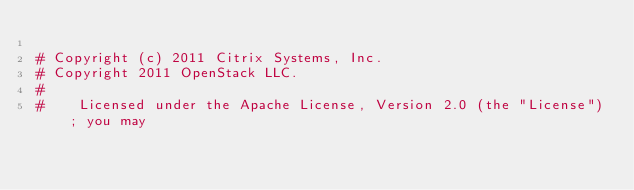Convert code to text. <code><loc_0><loc_0><loc_500><loc_500><_Python_>
# Copyright (c) 2011 Citrix Systems, Inc.
# Copyright 2011 OpenStack LLC.
#
#    Licensed under the Apache License, Version 2.0 (the "License"); you may</code> 